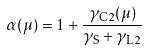<formula> <loc_0><loc_0><loc_500><loc_500>\alpha ( \mu ) = 1 + \frac { \gamma _ { \mathrm C 2 } ( \mu ) } { \gamma _ { \mathrm S } + \gamma _ { \mathrm L 2 } }</formula> 